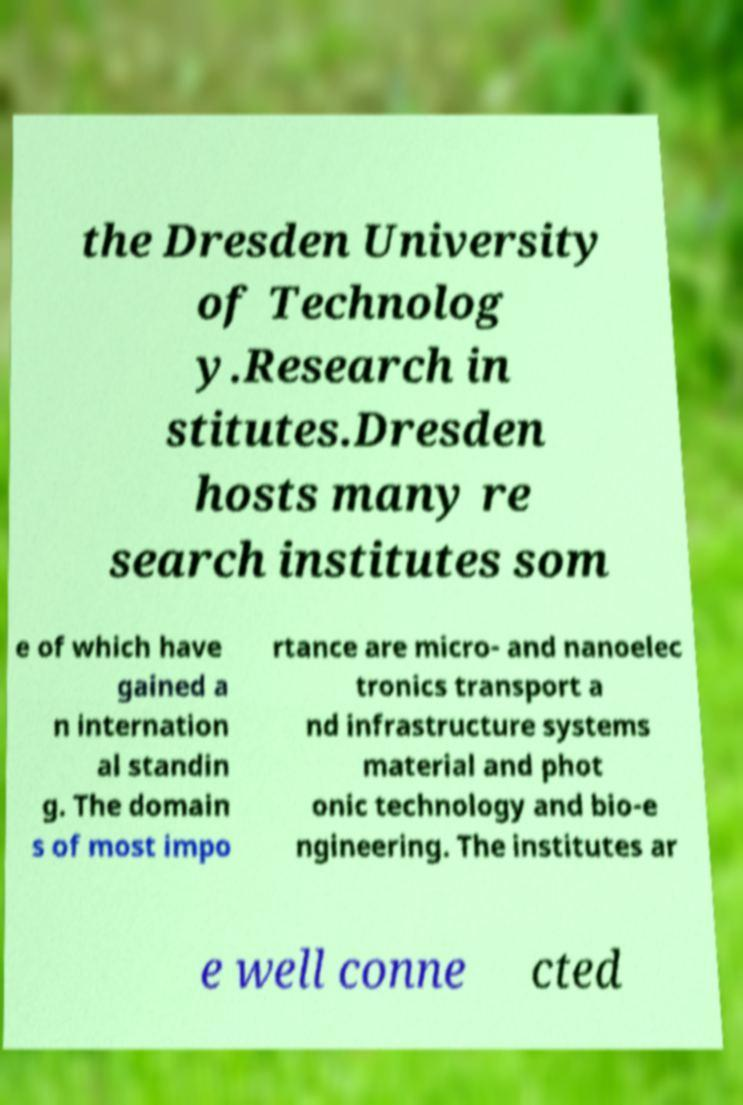Can you read and provide the text displayed in the image?This photo seems to have some interesting text. Can you extract and type it out for me? the Dresden University of Technolog y.Research in stitutes.Dresden hosts many re search institutes som e of which have gained a n internation al standin g. The domain s of most impo rtance are micro- and nanoelec tronics transport a nd infrastructure systems material and phot onic technology and bio-e ngineering. The institutes ar e well conne cted 